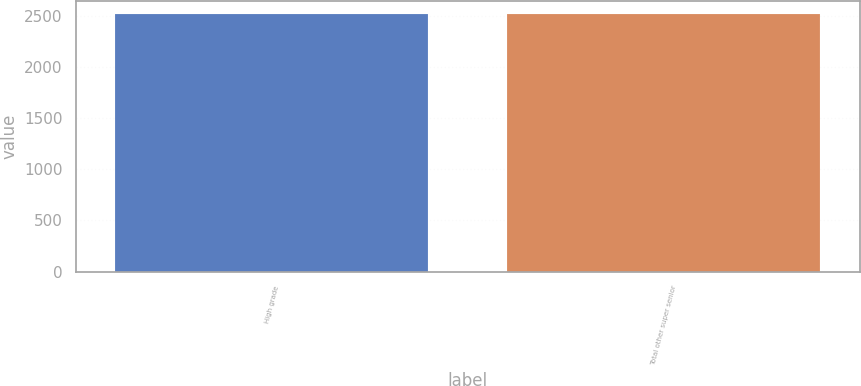<chart> <loc_0><loc_0><loc_500><loc_500><bar_chart><fcel>High grade<fcel>Total other super senior<nl><fcel>2519<fcel>2519.1<nl></chart> 